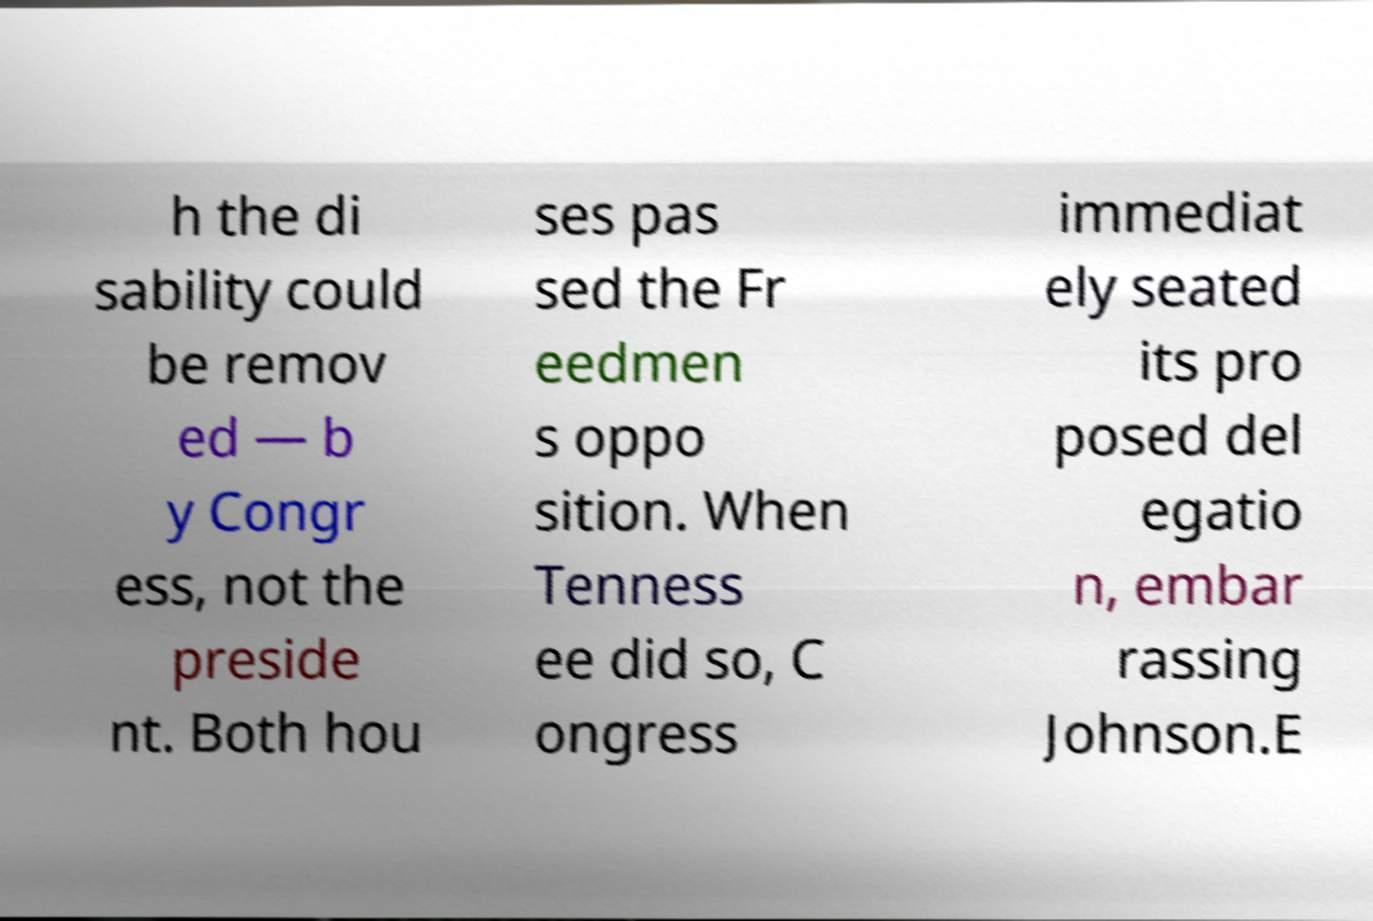Can you read and provide the text displayed in the image?This photo seems to have some interesting text. Can you extract and type it out for me? h the di sability could be remov ed — b y Congr ess, not the preside nt. Both hou ses pas sed the Fr eedmen s oppo sition. When Tenness ee did so, C ongress immediat ely seated its pro posed del egatio n, embar rassing Johnson.E 